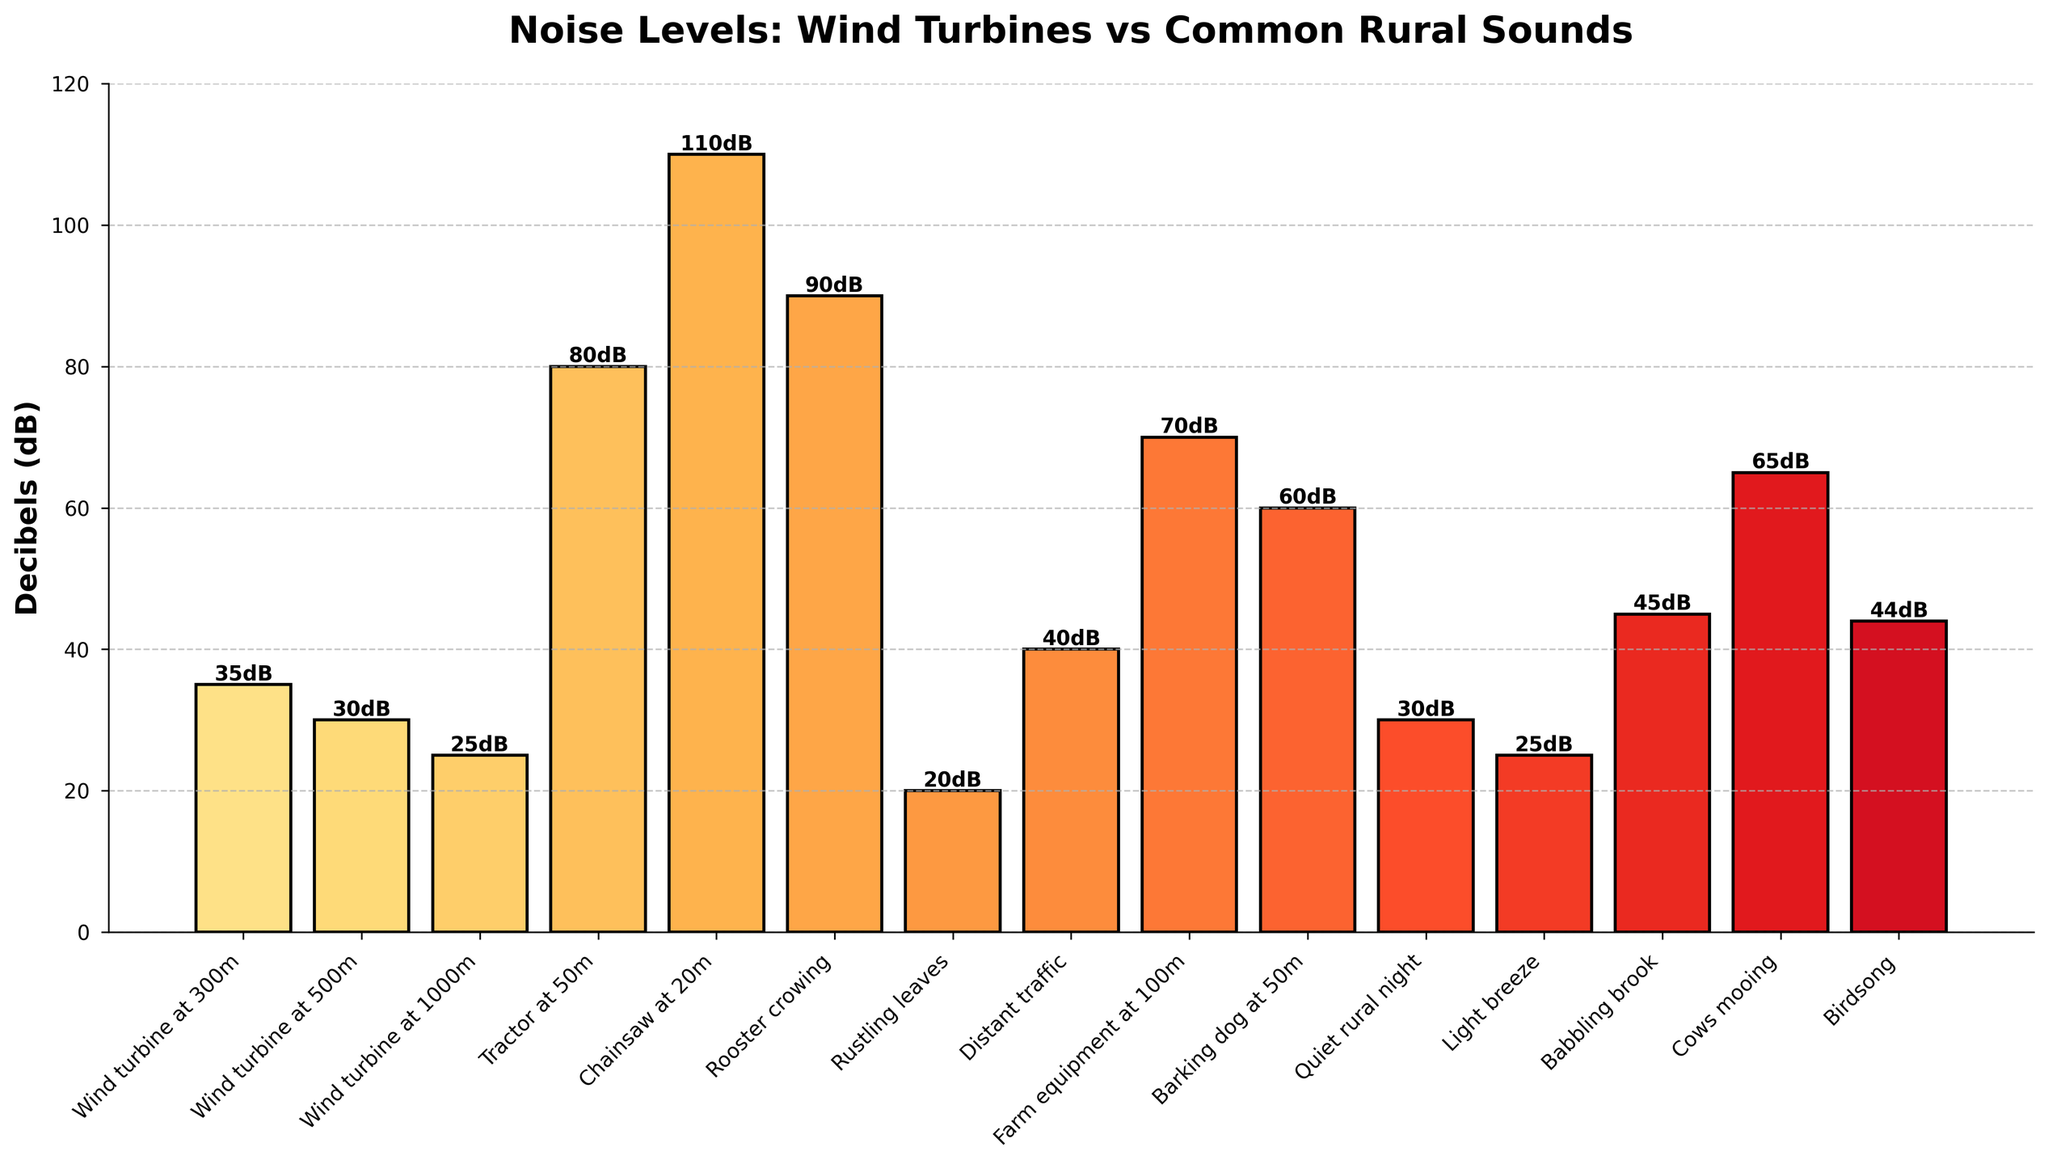Which sound source has the highest noise level? By visually inspecting the heights of the bars, it is clear that the Chainsaw at 20m has the highest noise level at 110 dB.
Answer: Chainsaw at 20m Which two sound sources have the same noise level? By examining the heights of the bars and their corresponding labels, both Wind turbine at 500m and Quiet rural night have a noise level of 30 dB.
Answer: Wind turbine at 500m and Quiet rural night What is the difference in noise levels between a Tractor at 50m and a Barking dog at 50m? The noise level of a Tractor at 50m is 80 dB, and the noise level of a Barking dog at 50m is 60 dB. Subtracting these values results in 80 - 60 = 20 dB.
Answer: 20 dB Which sound is louder, a Babbling brook or Birds singing? Comparing the heights of the bars, the Babbling brook has a noise level of 45 dB, while Birds singing has a noise level of 44 dB. Thus, the Babbling brook is louder.
Answer: Babbling brook How do the noise levels of Wind turbines compare to common rural sounds? The Wind turbines at various distances (300m: 35 dB, 500m: 30 dB, 1000m: 25 dB) show that their noise levels are relatively lower compared to louder common rural sounds like a Chainsaw (110 dB) or Rooster crowing (90 dB). Even at 300m, the wind turbine noise level (35 dB) is lower than the noise level of distant traffic (40 dB) and babbling brook (45 dB).
Answer: Wind turbines are generally quieter What is the average noise level of Wind turbines at different distances? The noise levels are 35 dB at 300m, 30 dB at 500m, and 25 dB at 1000m. Adding these values gives 35 + 30 + 25 = 90 dB. Dividing by the number of values results in 90 / 3 = 30 dB.
Answer: 30 dB Which sound source is quieter, rustling leaves or a light breeze, and by how much? Rustling leaves have a noise level of 20 dB, while a light breeze has a noise level of 25 dB. Subtracting these values gives 25 - 20 = 5 dB. Thus, rustling leaves are quieter by 5 dB.
Answer: Rustling leaves by 5 dB What is the combined noise level of a Rooster crowing and distant traffic? A Rooster crowing has a noise level of 90 dB, and distant traffic has a noise level of 40 dB. Adding these values together gives 90 + 40 = 130 dB.
Answer: 130 dB Which sound source is closest in noise level to a Wind turbine at 300m? Wind turbine at 300m has a noise level of 35 dB. Distant traffic has a noise level of 40 dB, which is the closest to 35 dB among the listed sources.
Answer: Distant traffic 